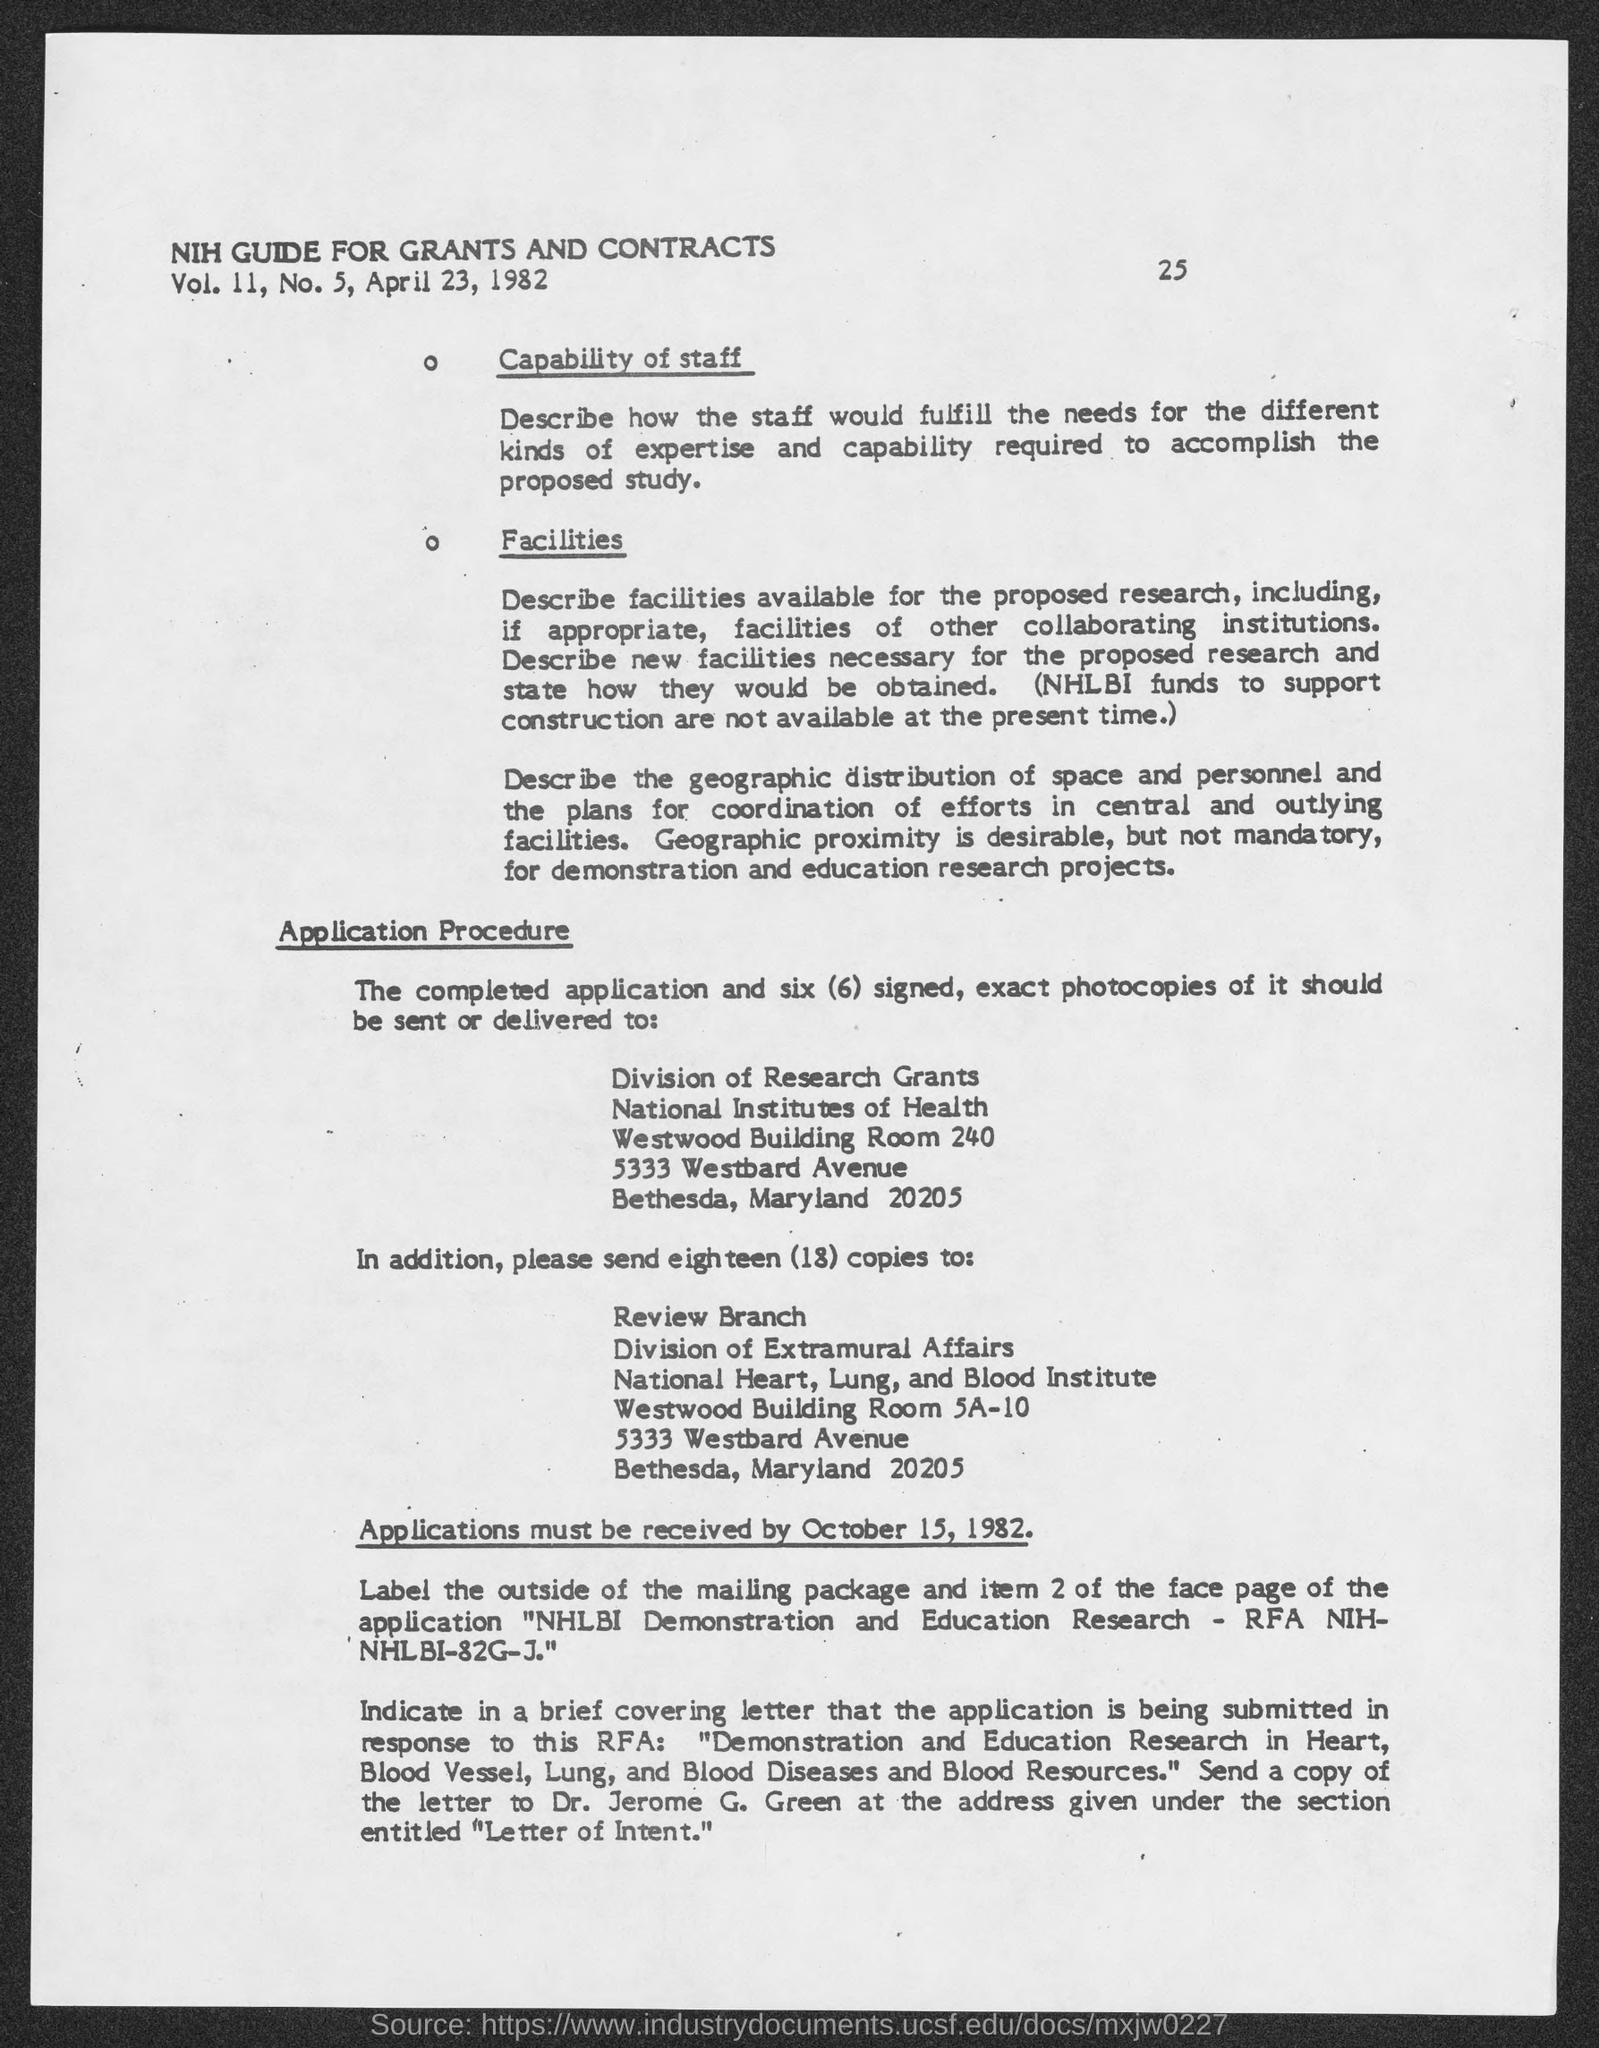List a handful of essential elements in this visual. The address of the National Institutes of Health is 5333 Westbard Avenue. The National Heart, Lung, and Blood Institute is located at 5333 Westbard Avenue. The deadline for submitting applications is October 15, 1982. The page number at the top of the page is 25. What is the volume of II No. 5? 